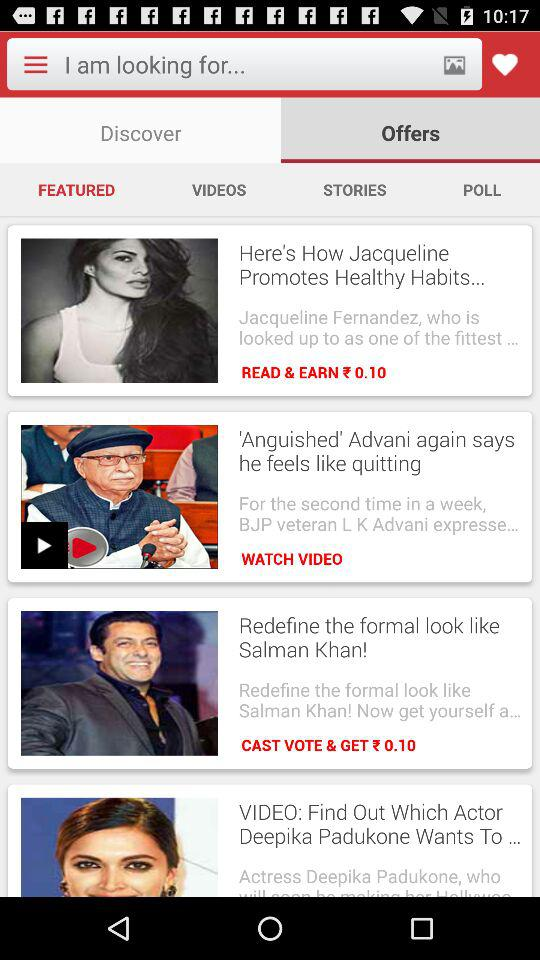How much will I get for casting a vote? You will get ₹0.10 for casting a vote. 